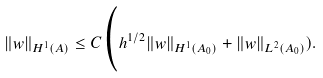<formula> <loc_0><loc_0><loc_500><loc_500>\| w \| _ { H ^ { 1 } ( A ) } \leq C \Big ( h ^ { 1 / 2 } \| w \| _ { H ^ { 1 } ( A _ { 0 } ) } + \| w \| _ { L ^ { 2 } ( A _ { 0 } ) } ) .</formula> 